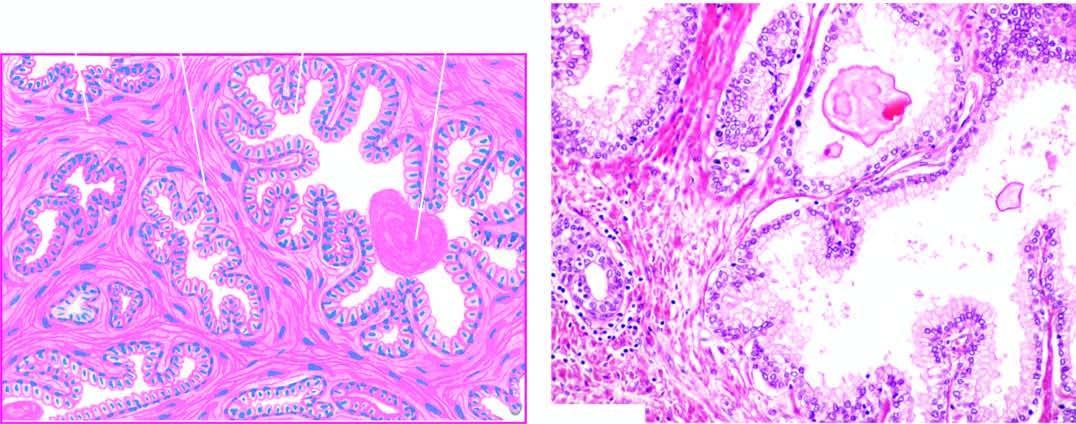what is there of fibromuscular elements?
Answer the question using a single word or phrase. Hyperplasia of fibromuscular elements 